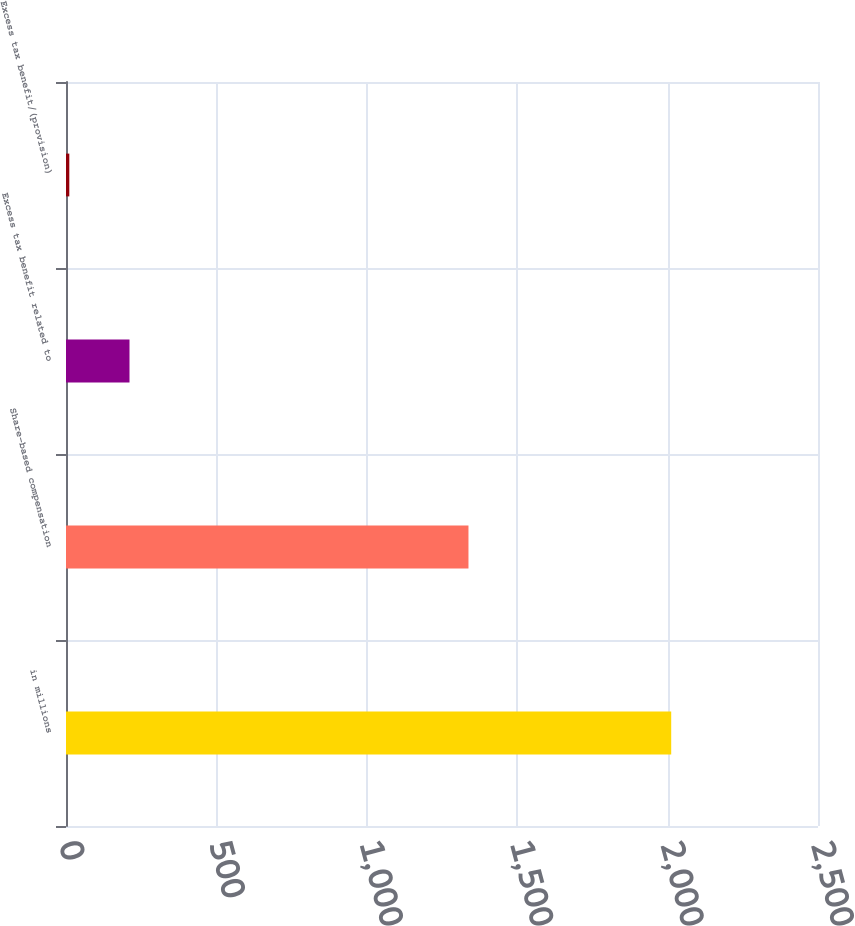<chart> <loc_0><loc_0><loc_500><loc_500><bar_chart><fcel>in millions<fcel>Share-based compensation<fcel>Excess tax benefit related to<fcel>Excess tax benefit/(provision)<nl><fcel>2012<fcel>1338<fcel>211.1<fcel>11<nl></chart> 